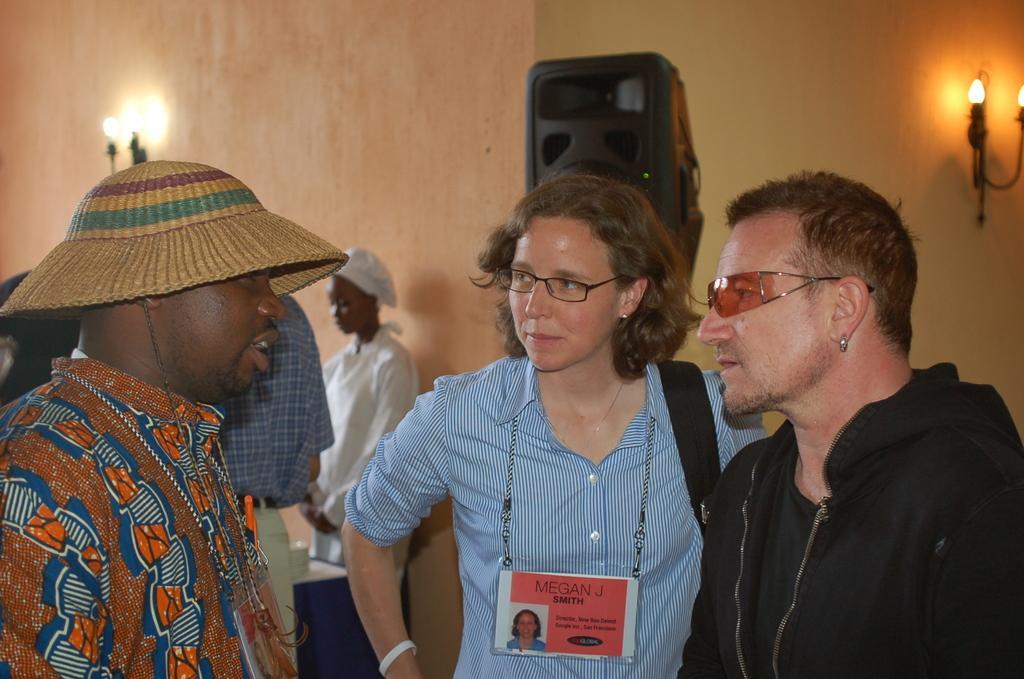Describe this image in one or two sentences. On the a man is talking, he wore that, shirt. In the middle a woman is listening to him, she wore shirt and an ID card. On the right side there is a man, he wore a black color coat and there are lights on the wall. 